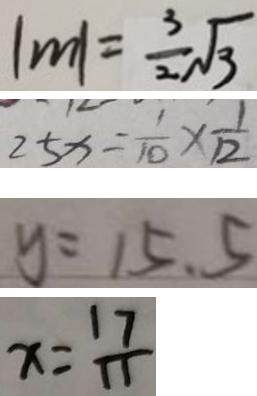Convert formula to latex. <formula><loc_0><loc_0><loc_500><loc_500>\vert m \vert = \frac { 3 } { 2 } \sqrt { 3 } 
 2 5 x = \frac { 1 } { 1 0 } \times \frac { 1 } { 1 2 } 
 y = 1 5 . 5 
 x = \frac { 1 7 } { 1 1 }</formula> 